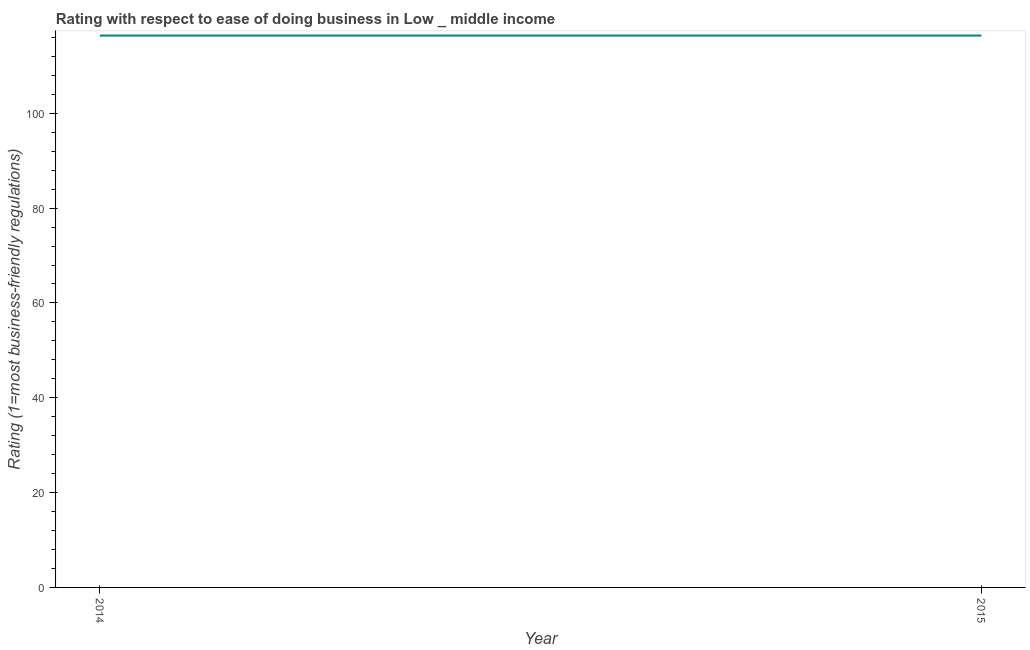What is the ease of doing business index in 2014?
Offer a terse response. 116.4. Across all years, what is the maximum ease of doing business index?
Your response must be concise. 116.4. Across all years, what is the minimum ease of doing business index?
Offer a terse response. 116.4. What is the sum of the ease of doing business index?
Keep it short and to the point. 232.79. What is the difference between the ease of doing business index in 2014 and 2015?
Keep it short and to the point. 0. What is the average ease of doing business index per year?
Give a very brief answer. 116.4. What is the median ease of doing business index?
Your answer should be very brief. 116.4. Do a majority of the years between 2015 and 2014 (inclusive) have ease of doing business index greater than 64 ?
Offer a very short reply. No. What is the ratio of the ease of doing business index in 2014 to that in 2015?
Provide a short and direct response. 1. Is the ease of doing business index in 2014 less than that in 2015?
Give a very brief answer. No. In how many years, is the ease of doing business index greater than the average ease of doing business index taken over all years?
Your answer should be very brief. 0. Does the ease of doing business index monotonically increase over the years?
Provide a short and direct response. No. How many lines are there?
Make the answer very short. 1. Are the values on the major ticks of Y-axis written in scientific E-notation?
Ensure brevity in your answer.  No. Does the graph contain any zero values?
Your response must be concise. No. What is the title of the graph?
Keep it short and to the point. Rating with respect to ease of doing business in Low _ middle income. What is the label or title of the Y-axis?
Offer a terse response. Rating (1=most business-friendly regulations). What is the Rating (1=most business-friendly regulations) in 2014?
Offer a terse response. 116.4. What is the Rating (1=most business-friendly regulations) in 2015?
Make the answer very short. 116.4. What is the difference between the Rating (1=most business-friendly regulations) in 2014 and 2015?
Offer a terse response. 0. What is the ratio of the Rating (1=most business-friendly regulations) in 2014 to that in 2015?
Make the answer very short. 1. 